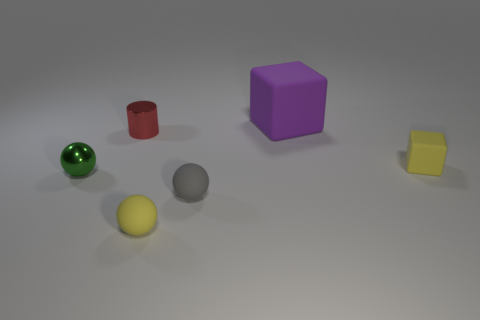Are there any other things that are the same size as the purple matte cube?
Make the answer very short. No. What number of other purple rubber blocks have the same size as the purple matte block?
Keep it short and to the point. 0. Are there more cubes in front of the big block than small green metallic balls to the right of the yellow cube?
Your answer should be compact. Yes. What is the material of the red object that is the same size as the green metal object?
Provide a succinct answer. Metal. The large purple matte object is what shape?
Offer a terse response. Cube. What number of purple objects are big cubes or shiny spheres?
Your answer should be very brief. 1. There is a purple thing that is the same material as the yellow sphere; what size is it?
Provide a short and direct response. Large. Is the thing that is to the left of the small shiny cylinder made of the same material as the cube that is behind the yellow rubber cube?
Your answer should be compact. No. How many cylinders are either small red shiny things or yellow objects?
Your response must be concise. 1. How many rubber cubes are behind the yellow rubber thing that is on the right side of the yellow matte object in front of the gray matte thing?
Your answer should be very brief. 1. 